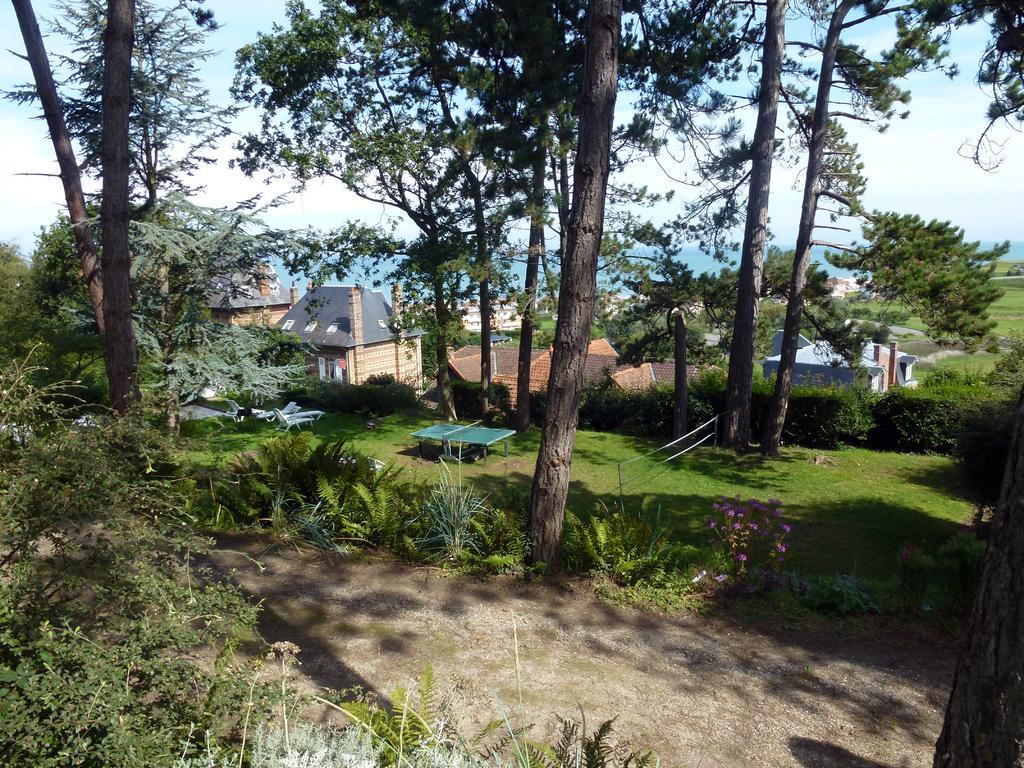Can you describe this image briefly? In this image I can see the plants and many trees. I can see the purple color flowers to the plant. There are some beach beds, table tennis and the net. In the background I can see the houses, water, clouds and the sky. 